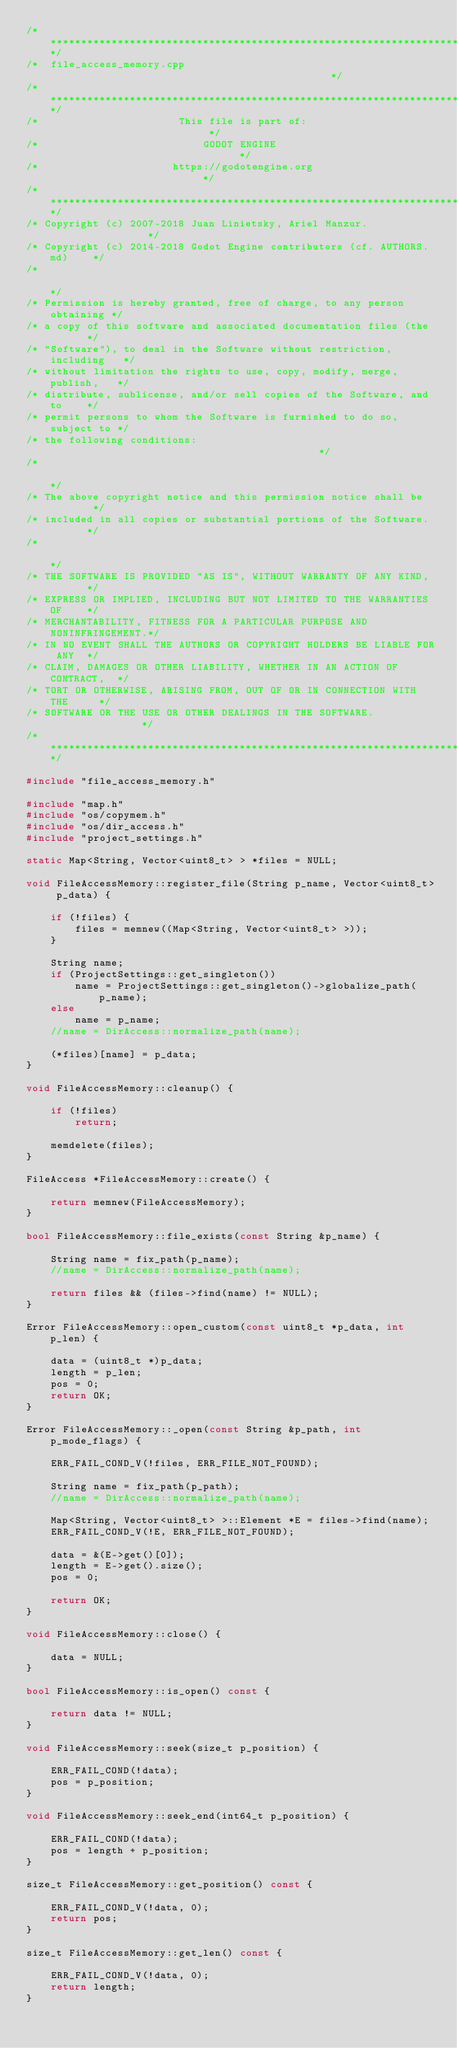<code> <loc_0><loc_0><loc_500><loc_500><_C++_>/*************************************************************************/
/*  file_access_memory.cpp                                               */
/*************************************************************************/
/*                       This file is part of:                           */
/*                           GODOT ENGINE                                */
/*                      https://godotengine.org                          */
/*************************************************************************/
/* Copyright (c) 2007-2018 Juan Linietsky, Ariel Manzur.                 */
/* Copyright (c) 2014-2018 Godot Engine contributors (cf. AUTHORS.md)    */
/*                                                                       */
/* Permission is hereby granted, free of charge, to any person obtaining */
/* a copy of this software and associated documentation files (the       */
/* "Software"), to deal in the Software without restriction, including   */
/* without limitation the rights to use, copy, modify, merge, publish,   */
/* distribute, sublicense, and/or sell copies of the Software, and to    */
/* permit persons to whom the Software is furnished to do so, subject to */
/* the following conditions:                                             */
/*                                                                       */
/* The above copyright notice and this permission notice shall be        */
/* included in all copies or substantial portions of the Software.       */
/*                                                                       */
/* THE SOFTWARE IS PROVIDED "AS IS", WITHOUT WARRANTY OF ANY KIND,       */
/* EXPRESS OR IMPLIED, INCLUDING BUT NOT LIMITED TO THE WARRANTIES OF    */
/* MERCHANTABILITY, FITNESS FOR A PARTICULAR PURPOSE AND NONINFRINGEMENT.*/
/* IN NO EVENT SHALL THE AUTHORS OR COPYRIGHT HOLDERS BE LIABLE FOR ANY  */
/* CLAIM, DAMAGES OR OTHER LIABILITY, WHETHER IN AN ACTION OF CONTRACT,  */
/* TORT OR OTHERWISE, ARISING FROM, OUT OF OR IN CONNECTION WITH THE     */
/* SOFTWARE OR THE USE OR OTHER DEALINGS IN THE SOFTWARE.                */
/*************************************************************************/

#include "file_access_memory.h"

#include "map.h"
#include "os/copymem.h"
#include "os/dir_access.h"
#include "project_settings.h"

static Map<String, Vector<uint8_t> > *files = NULL;

void FileAccessMemory::register_file(String p_name, Vector<uint8_t> p_data) {

	if (!files) {
		files = memnew((Map<String, Vector<uint8_t> >));
	}

	String name;
	if (ProjectSettings::get_singleton())
		name = ProjectSettings::get_singleton()->globalize_path(p_name);
	else
		name = p_name;
	//name = DirAccess::normalize_path(name);

	(*files)[name] = p_data;
}

void FileAccessMemory::cleanup() {

	if (!files)
		return;

	memdelete(files);
}

FileAccess *FileAccessMemory::create() {

	return memnew(FileAccessMemory);
}

bool FileAccessMemory::file_exists(const String &p_name) {

	String name = fix_path(p_name);
	//name = DirAccess::normalize_path(name);

	return files && (files->find(name) != NULL);
}

Error FileAccessMemory::open_custom(const uint8_t *p_data, int p_len) {

	data = (uint8_t *)p_data;
	length = p_len;
	pos = 0;
	return OK;
}

Error FileAccessMemory::_open(const String &p_path, int p_mode_flags) {

	ERR_FAIL_COND_V(!files, ERR_FILE_NOT_FOUND);

	String name = fix_path(p_path);
	//name = DirAccess::normalize_path(name);

	Map<String, Vector<uint8_t> >::Element *E = files->find(name);
	ERR_FAIL_COND_V(!E, ERR_FILE_NOT_FOUND);

	data = &(E->get()[0]);
	length = E->get().size();
	pos = 0;

	return OK;
}

void FileAccessMemory::close() {

	data = NULL;
}

bool FileAccessMemory::is_open() const {

	return data != NULL;
}

void FileAccessMemory::seek(size_t p_position) {

	ERR_FAIL_COND(!data);
	pos = p_position;
}

void FileAccessMemory::seek_end(int64_t p_position) {

	ERR_FAIL_COND(!data);
	pos = length + p_position;
}

size_t FileAccessMemory::get_position() const {

	ERR_FAIL_COND_V(!data, 0);
	return pos;
}

size_t FileAccessMemory::get_len() const {

	ERR_FAIL_COND_V(!data, 0);
	return length;
}
</code> 